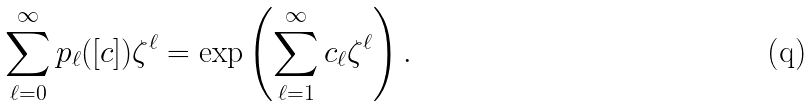<formula> <loc_0><loc_0><loc_500><loc_500>\sum _ { \ell = 0 } ^ { \infty } p _ { \ell } ( [ c ] ) \zeta ^ { \ell } = \exp \left ( \sum _ { \ell = 1 } ^ { \infty } c _ { \ell } \zeta ^ { \ell } \right ) .</formula> 